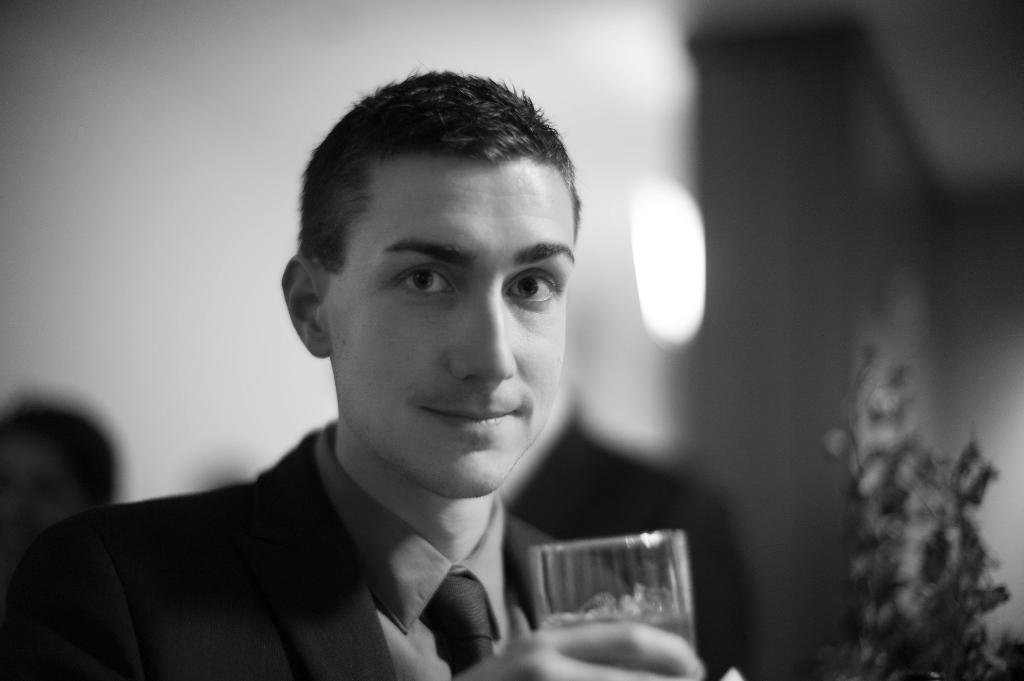What is the person in the image holding? The person is holding a glass in the image. What can be seen on the right side of the image? There is a plant on the right side of the image. What is visible in the background of the image? There is a wall in the background of the image. How is the image presented in terms of color? The image is in black and white. What type of skirt is the person wearing in the image? There is no skirt visible in the image, as the person is not wearing one. 